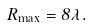<formula> <loc_0><loc_0><loc_500><loc_500>R _ { \max } = 8 \lambda .</formula> 